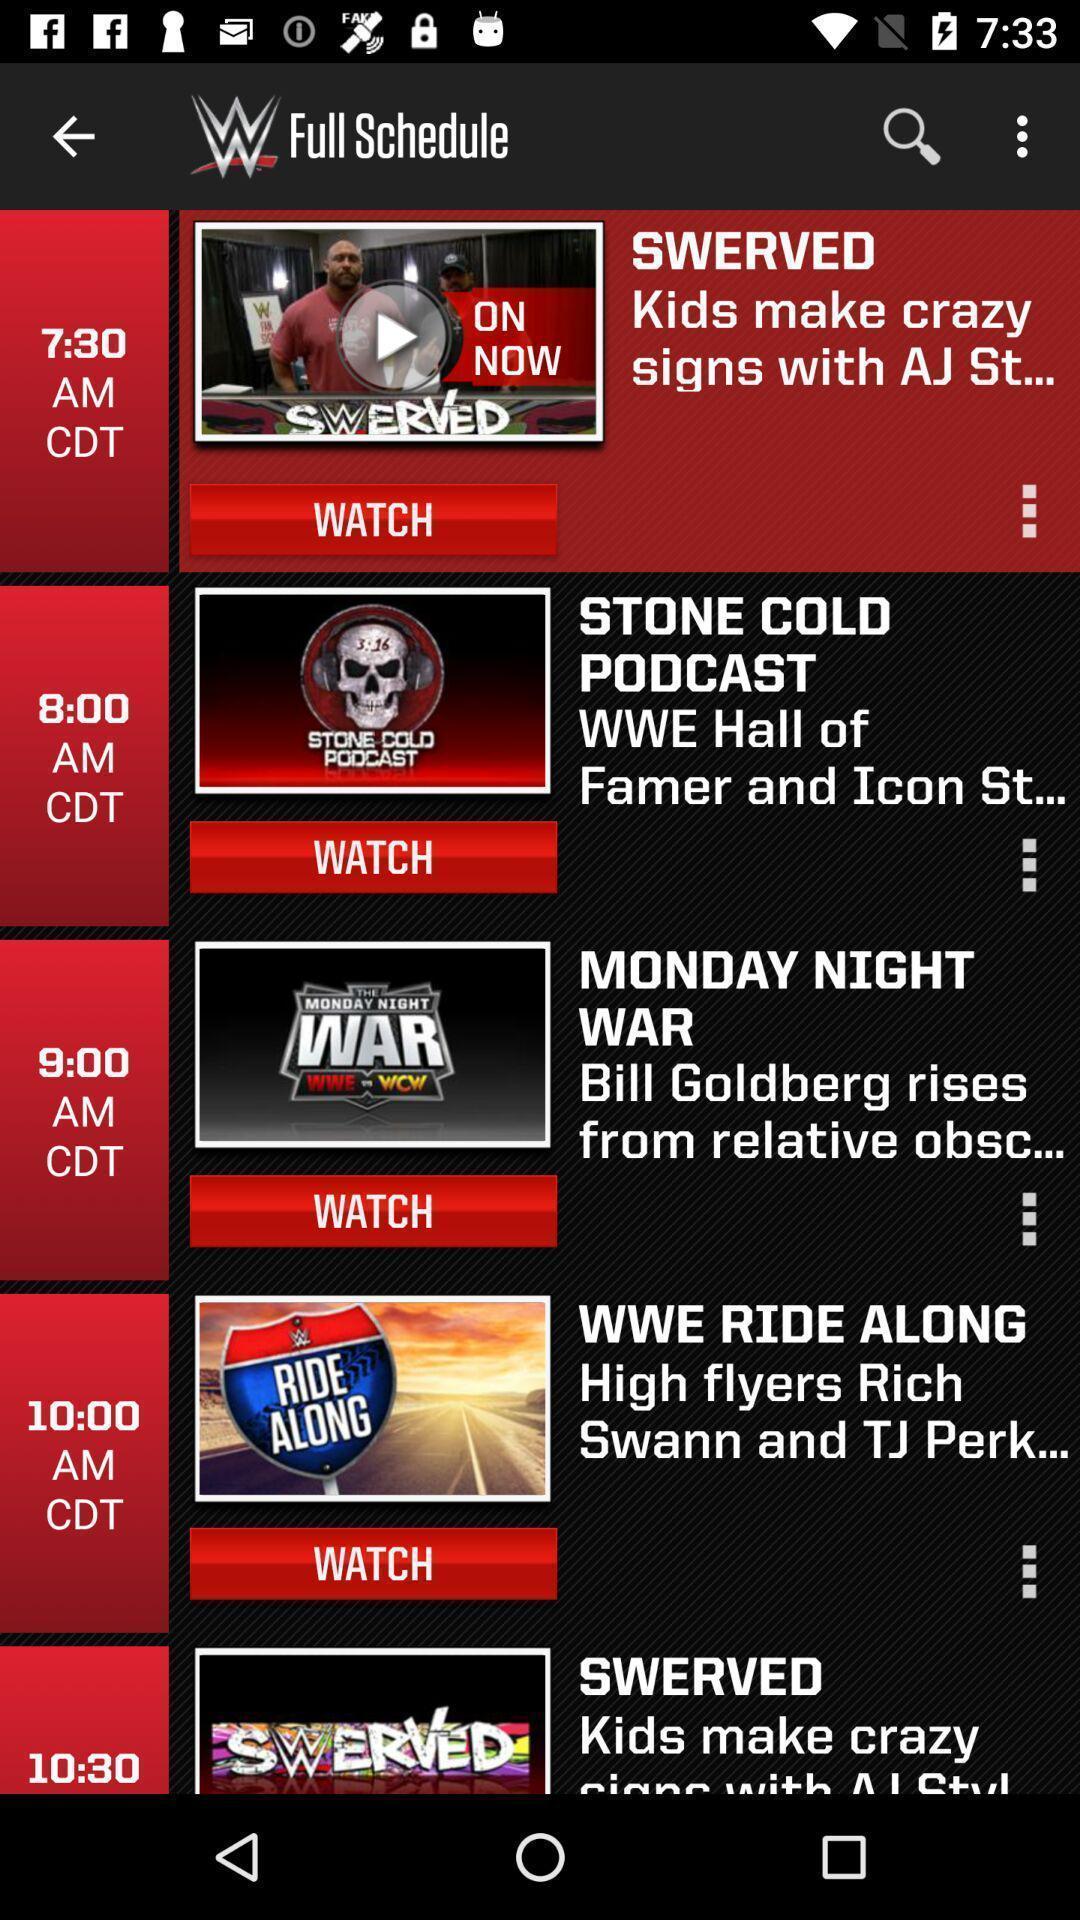Provide a description of this screenshot. Page showing the full schedule. 